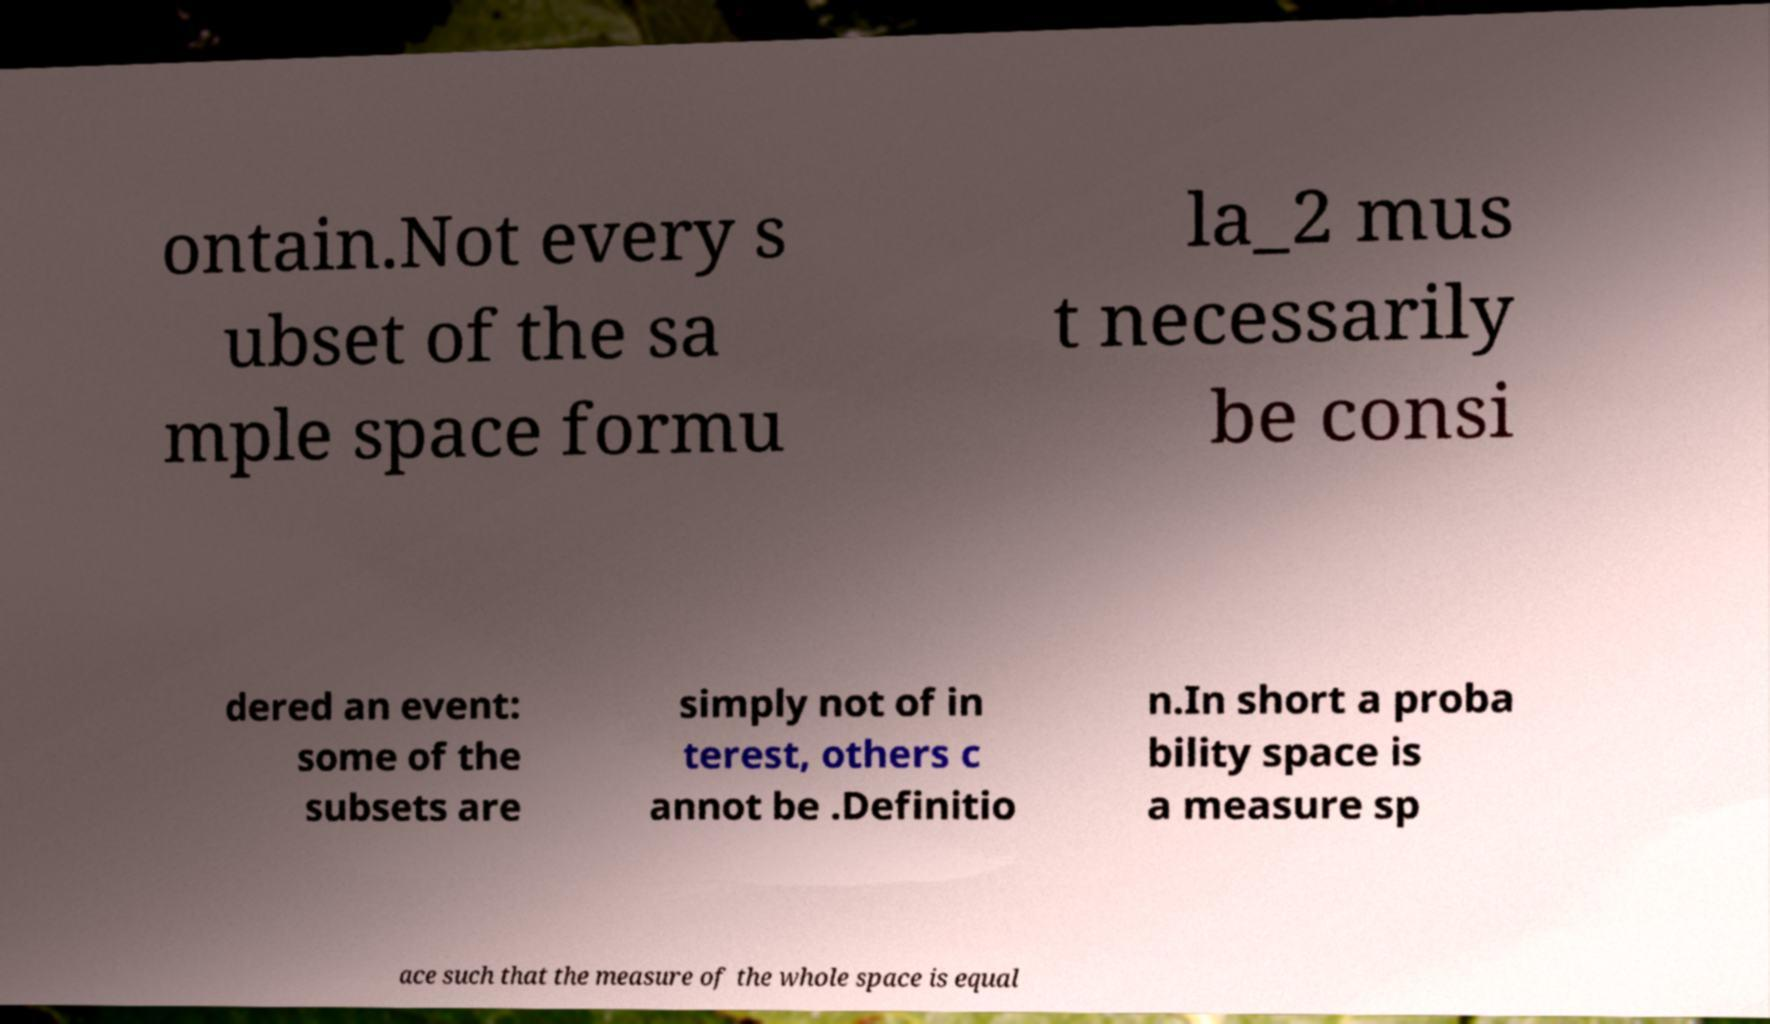Could you assist in decoding the text presented in this image and type it out clearly? ontain.Not every s ubset of the sa mple space formu la_2 mus t necessarily be consi dered an event: some of the subsets are simply not of in terest, others c annot be .Definitio n.In short a proba bility space is a measure sp ace such that the measure of the whole space is equal 